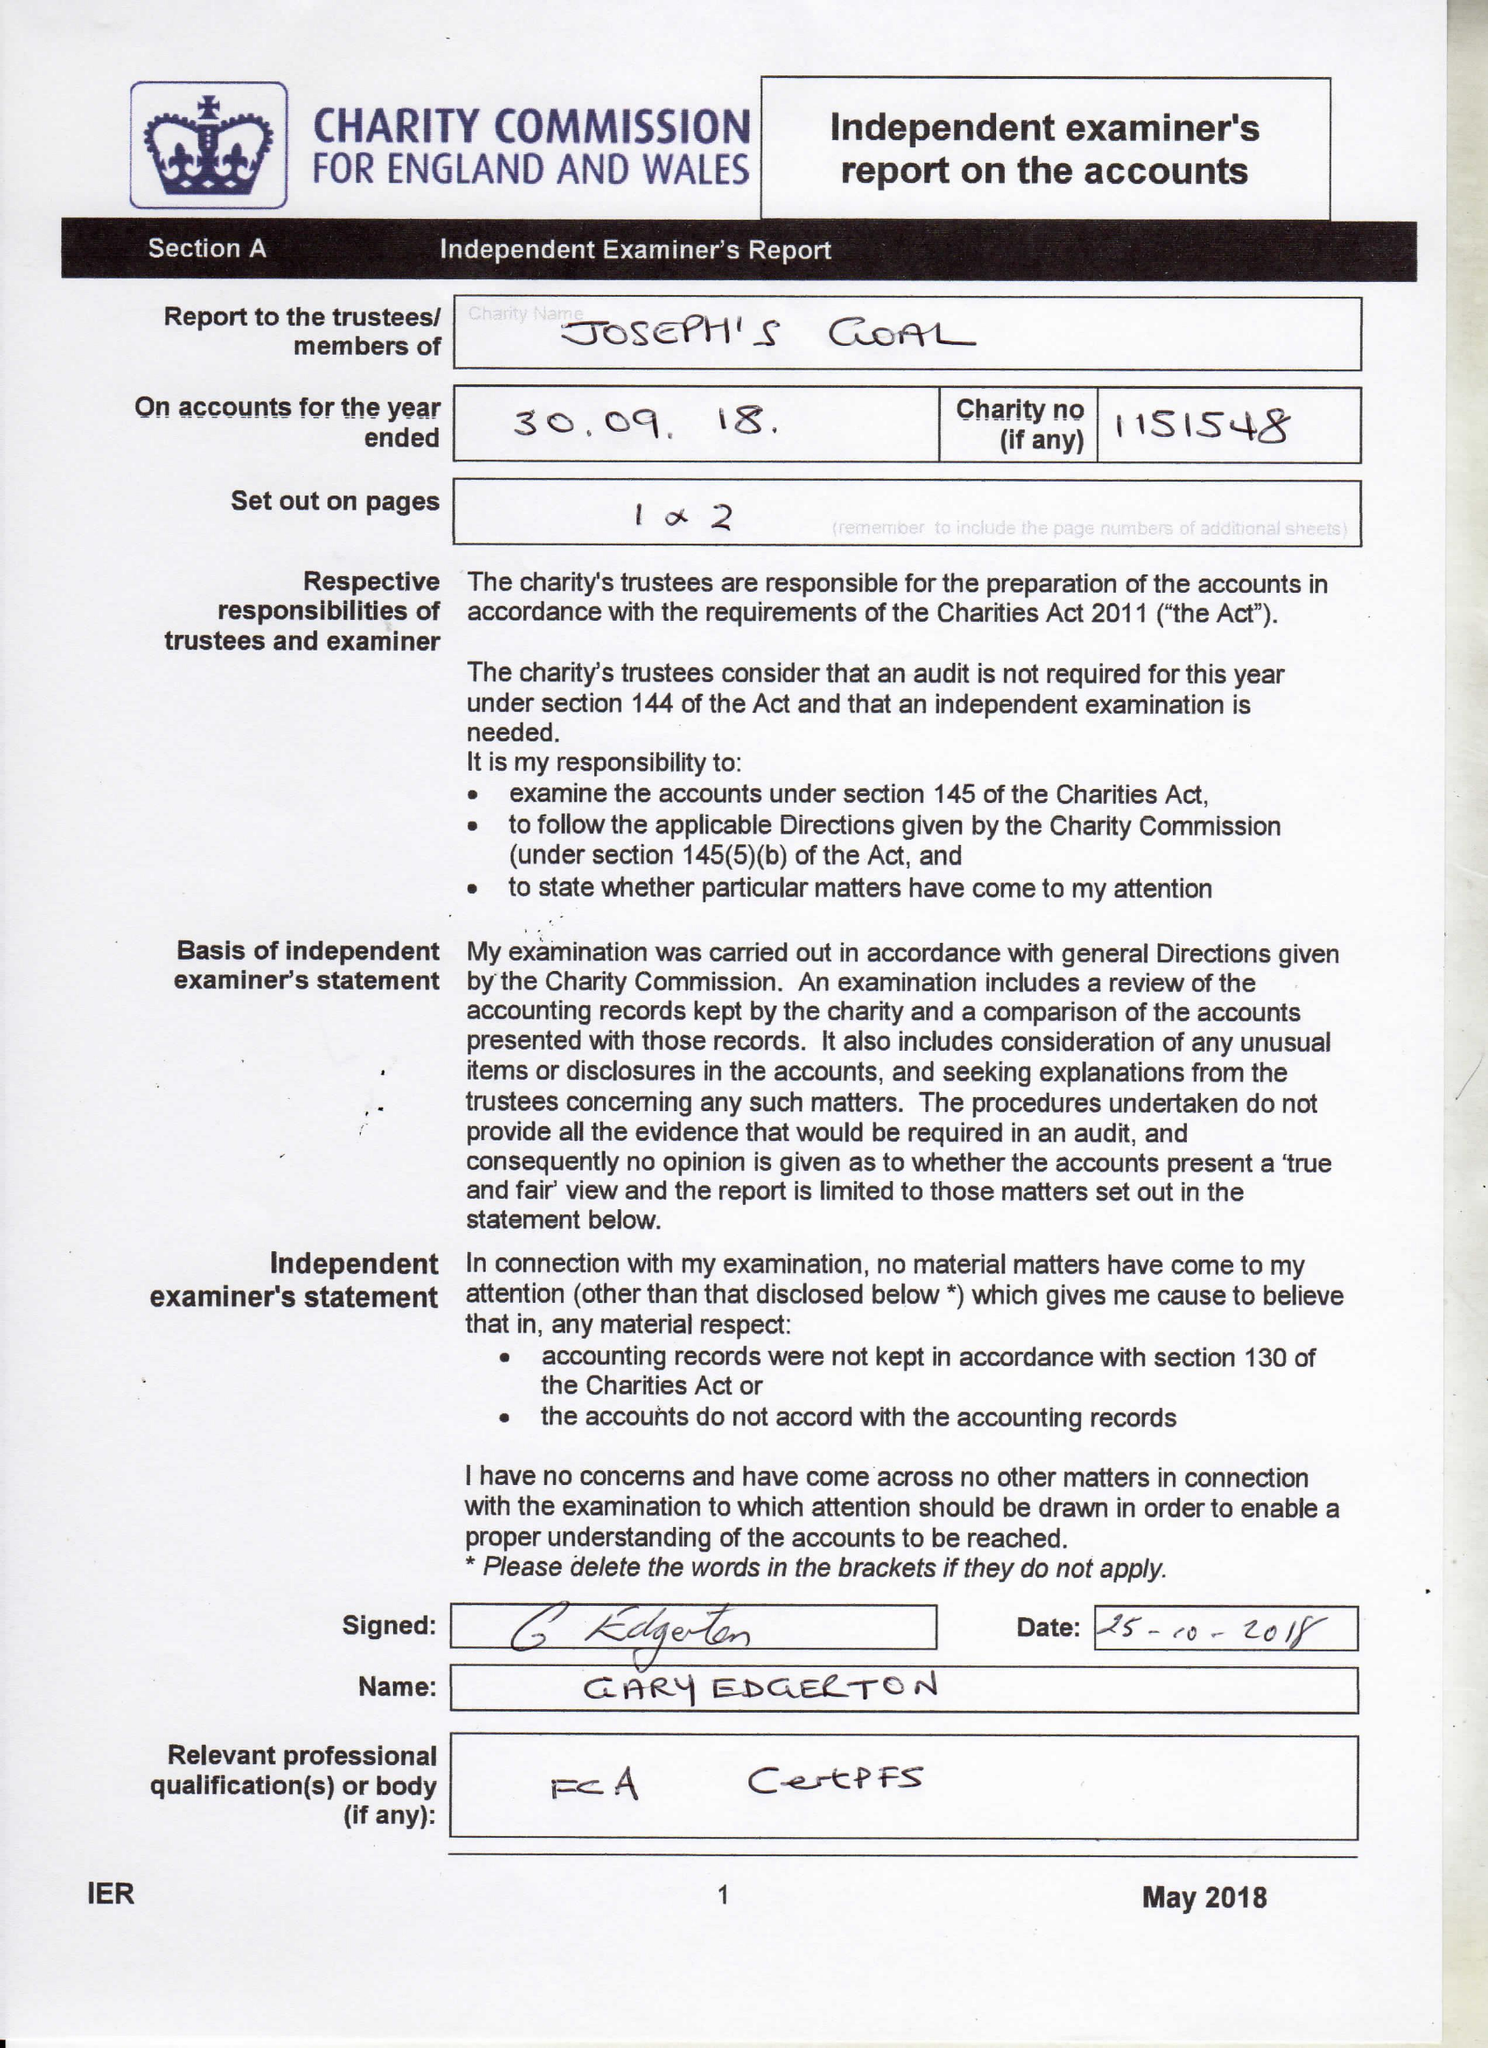What is the value for the address__street_line?
Answer the question using a single word or phrase. 59 SPRING ROAD 